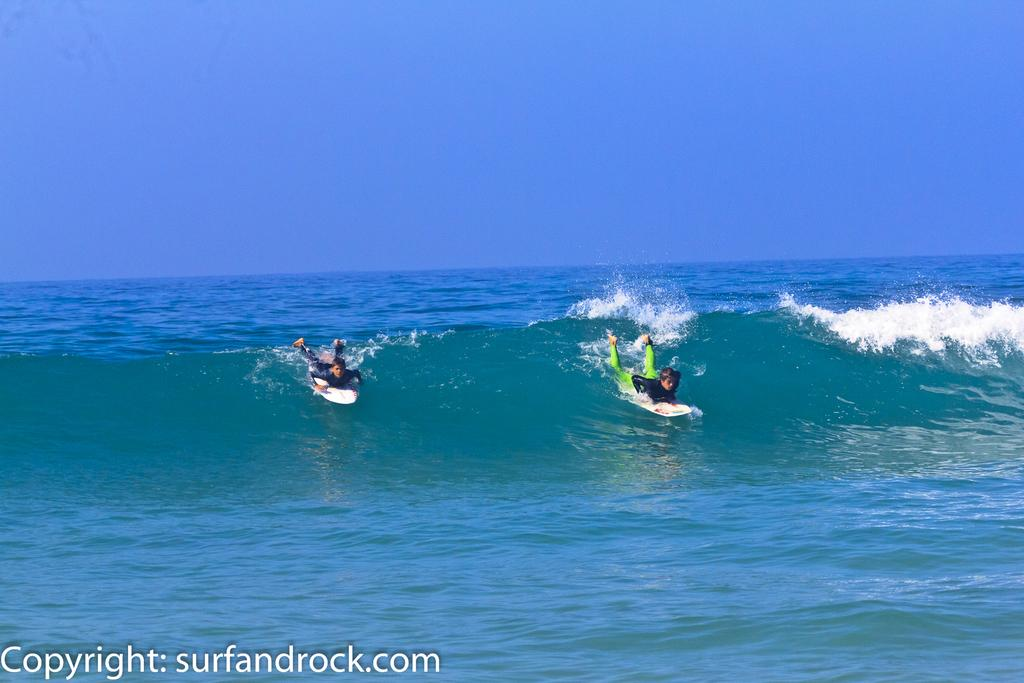How many people are in the image? There are two persons in the image. What are the persons doing in the image? The persons are surfing on the sea. Is there any text or marking on the image? Yes, there is a watermark at the bottom of the image. What can be seen above the persons in the image? The sky is visible at the top of the image. What type of approval is required for the persons to surf in the image? There is no indication in the image that any approval is required for the persons to surf. Can you see a bag in the image? No, there is no bag visible in the image. 